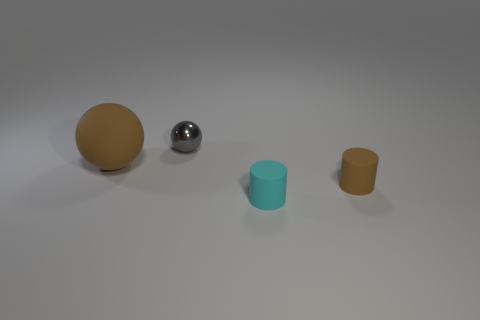Subtract all gray balls. How many balls are left? 1 Subtract 1 cylinders. How many cylinders are left? 1 Subtract all gray cylinders. How many green spheres are left? 0 Add 3 small cylinders. How many objects exist? 7 Add 2 small blue rubber balls. How many small blue rubber balls exist? 2 Subtract 1 brown balls. How many objects are left? 3 Subtract all red balls. Subtract all brown cylinders. How many balls are left? 2 Subtract all brown balls. Subtract all large purple metallic things. How many objects are left? 3 Add 1 gray shiny balls. How many gray shiny balls are left? 2 